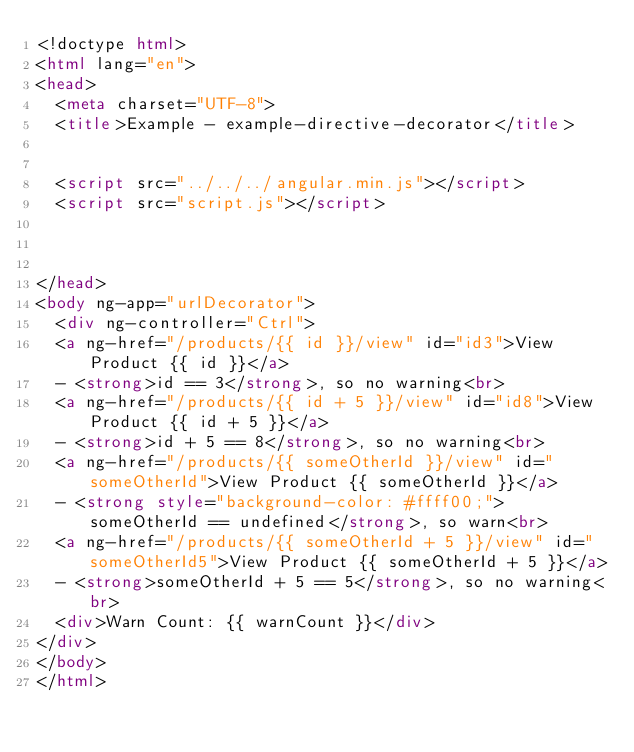Convert code to text. <code><loc_0><loc_0><loc_500><loc_500><_HTML_><!doctype html>
<html lang="en">
<head>
  <meta charset="UTF-8">
  <title>Example - example-directive-decorator</title>
  

  <script src="../../../angular.min.js"></script>
  <script src="script.js"></script>
  

  
</head>
<body ng-app="urlDecorator">
  <div ng-controller="Ctrl">
  <a ng-href="/products/{{ id }}/view" id="id3">View Product {{ id }}</a>
  - <strong>id == 3</strong>, so no warning<br>
  <a ng-href="/products/{{ id + 5 }}/view" id="id8">View Product {{ id + 5 }}</a>
  - <strong>id + 5 == 8</strong>, so no warning<br>
  <a ng-href="/products/{{ someOtherId }}/view" id="someOtherId">View Product {{ someOtherId }}</a>
  - <strong style="background-color: #ffff00;">someOtherId == undefined</strong>, so warn<br>
  <a ng-href="/products/{{ someOtherId + 5 }}/view" id="someOtherId5">View Product {{ someOtherId + 5 }}</a>
  - <strong>someOtherId + 5 == 5</strong>, so no warning<br>
  <div>Warn Count: {{ warnCount }}</div>
</div>
</body>
</html></code> 